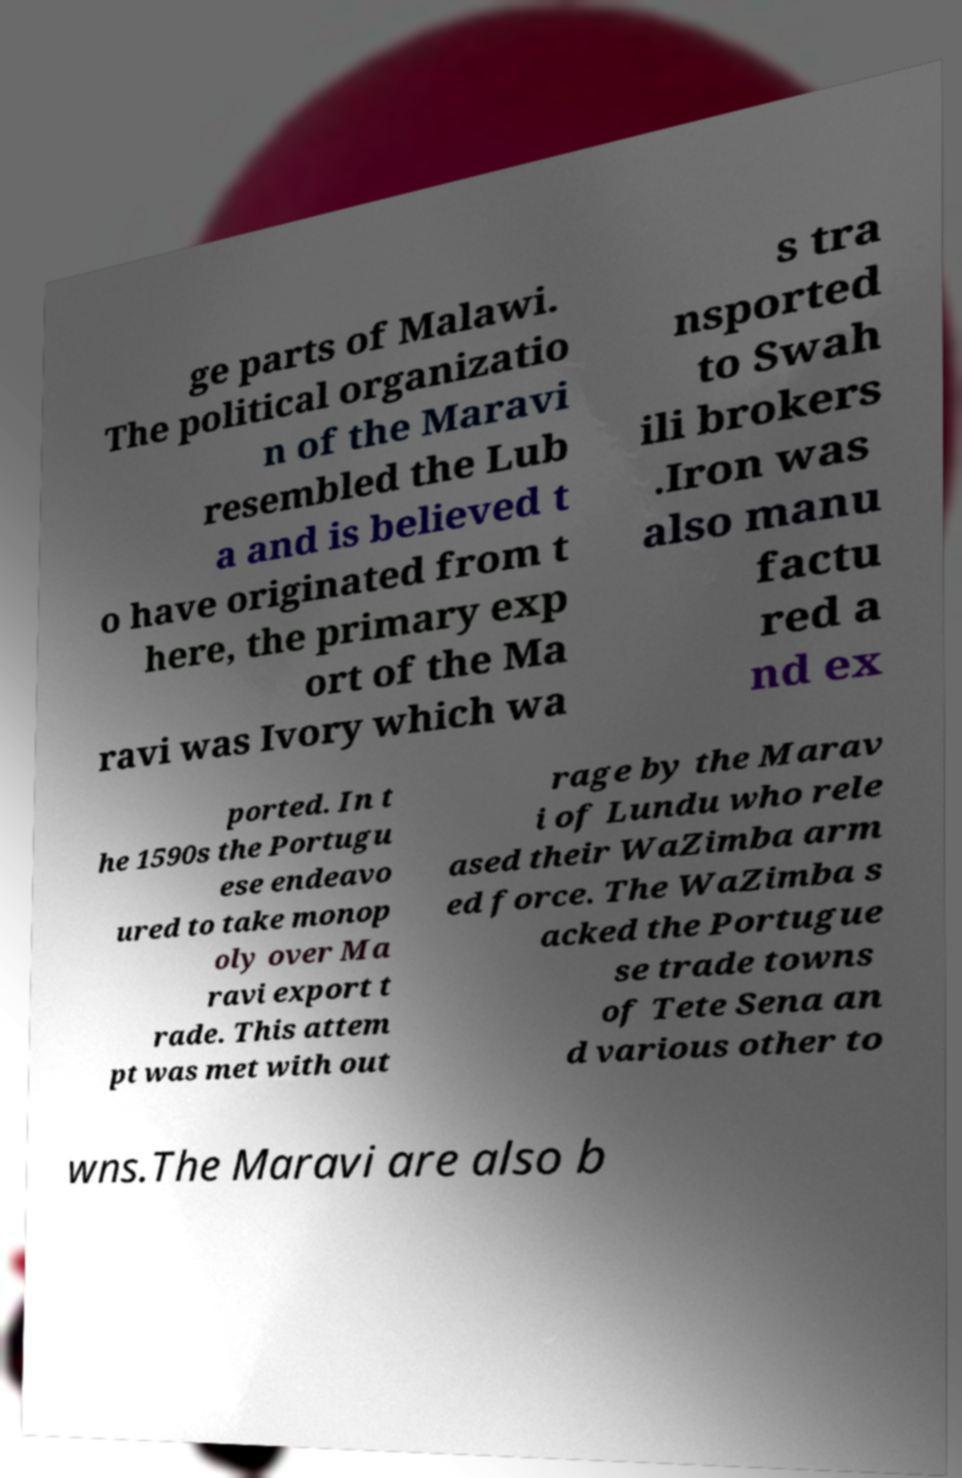Please read and relay the text visible in this image. What does it say? ge parts of Malawi. The political organizatio n of the Maravi resembled the Lub a and is believed t o have originated from t here, the primary exp ort of the Ma ravi was Ivory which wa s tra nsported to Swah ili brokers .Iron was also manu factu red a nd ex ported. In t he 1590s the Portugu ese endeavo ured to take monop oly over Ma ravi export t rade. This attem pt was met with out rage by the Marav i of Lundu who rele ased their WaZimba arm ed force. The WaZimba s acked the Portugue se trade towns of Tete Sena an d various other to wns.The Maravi are also b 